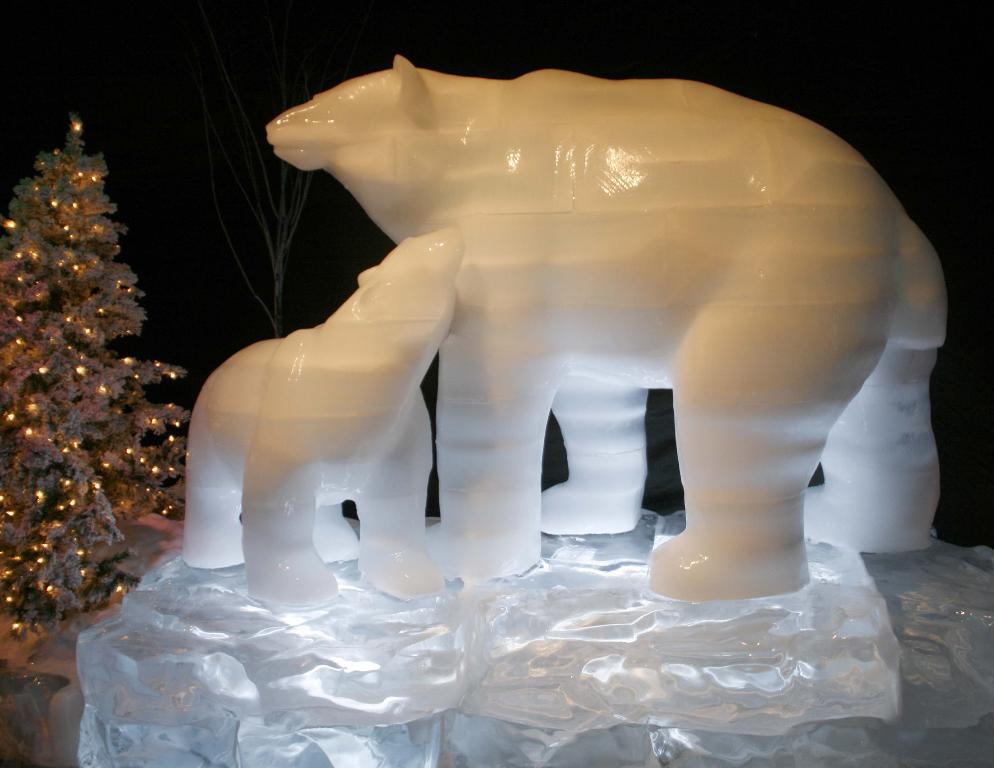Please provide a concise description of this image. In this picture, we see the sculpture of the polar bear. On the left side, we see the Christmas tree which is decorated with the lights. In the background, it is black in color and this picture might be clicked in the dark. 